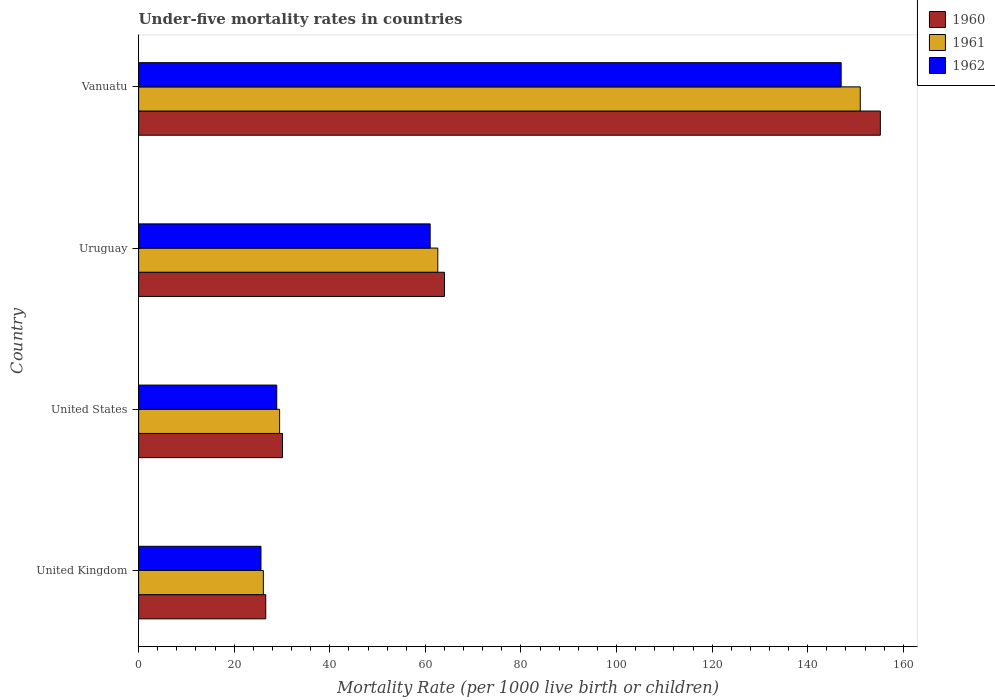How many different coloured bars are there?
Your response must be concise. 3. How many groups of bars are there?
Make the answer very short. 4. Are the number of bars per tick equal to the number of legend labels?
Your response must be concise. Yes. What is the label of the 4th group of bars from the top?
Offer a very short reply. United Kingdom. What is the under-five mortality rate in 1962 in United Kingdom?
Your answer should be very brief. 25.6. Across all countries, what is the maximum under-five mortality rate in 1960?
Offer a terse response. 155.2. Across all countries, what is the minimum under-five mortality rate in 1960?
Your response must be concise. 26.6. In which country was the under-five mortality rate in 1961 maximum?
Keep it short and to the point. Vanuatu. What is the total under-five mortality rate in 1962 in the graph?
Your answer should be very brief. 262.5. What is the difference between the under-five mortality rate in 1962 in United States and that in Vanuatu?
Give a very brief answer. -118.1. What is the difference between the under-five mortality rate in 1962 in United Kingdom and the under-five mortality rate in 1960 in United States?
Make the answer very short. -4.5. What is the average under-five mortality rate in 1960 per country?
Offer a very short reply. 68.97. What is the difference between the under-five mortality rate in 1962 and under-five mortality rate in 1961 in Uruguay?
Provide a succinct answer. -1.6. In how many countries, is the under-five mortality rate in 1961 greater than 76 ?
Keep it short and to the point. 1. What is the ratio of the under-five mortality rate in 1960 in United States to that in Uruguay?
Make the answer very short. 0.47. What is the difference between the highest and the lowest under-five mortality rate in 1962?
Offer a terse response. 121.4. In how many countries, is the under-five mortality rate in 1960 greater than the average under-five mortality rate in 1960 taken over all countries?
Ensure brevity in your answer.  1. What does the 2nd bar from the bottom in Vanuatu represents?
Provide a short and direct response. 1961. Is it the case that in every country, the sum of the under-five mortality rate in 1962 and under-five mortality rate in 1960 is greater than the under-five mortality rate in 1961?
Your answer should be very brief. Yes. How many bars are there?
Your response must be concise. 12. Are all the bars in the graph horizontal?
Ensure brevity in your answer.  Yes. What is the difference between two consecutive major ticks on the X-axis?
Provide a short and direct response. 20. Are the values on the major ticks of X-axis written in scientific E-notation?
Provide a short and direct response. No. Does the graph contain grids?
Ensure brevity in your answer.  No. Where does the legend appear in the graph?
Keep it short and to the point. Top right. How many legend labels are there?
Give a very brief answer. 3. What is the title of the graph?
Ensure brevity in your answer.  Under-five mortality rates in countries. What is the label or title of the X-axis?
Your answer should be very brief. Mortality Rate (per 1000 live birth or children). What is the label or title of the Y-axis?
Offer a very short reply. Country. What is the Mortality Rate (per 1000 live birth or children) in 1960 in United Kingdom?
Provide a succinct answer. 26.6. What is the Mortality Rate (per 1000 live birth or children) in 1961 in United Kingdom?
Your answer should be very brief. 26.1. What is the Mortality Rate (per 1000 live birth or children) in 1962 in United Kingdom?
Offer a terse response. 25.6. What is the Mortality Rate (per 1000 live birth or children) in 1960 in United States?
Make the answer very short. 30.1. What is the Mortality Rate (per 1000 live birth or children) in 1961 in United States?
Keep it short and to the point. 29.5. What is the Mortality Rate (per 1000 live birth or children) in 1962 in United States?
Offer a terse response. 28.9. What is the Mortality Rate (per 1000 live birth or children) in 1961 in Uruguay?
Provide a short and direct response. 62.6. What is the Mortality Rate (per 1000 live birth or children) in 1960 in Vanuatu?
Offer a very short reply. 155.2. What is the Mortality Rate (per 1000 live birth or children) of 1961 in Vanuatu?
Provide a succinct answer. 151. What is the Mortality Rate (per 1000 live birth or children) in 1962 in Vanuatu?
Make the answer very short. 147. Across all countries, what is the maximum Mortality Rate (per 1000 live birth or children) of 1960?
Give a very brief answer. 155.2. Across all countries, what is the maximum Mortality Rate (per 1000 live birth or children) of 1961?
Your response must be concise. 151. Across all countries, what is the maximum Mortality Rate (per 1000 live birth or children) in 1962?
Provide a succinct answer. 147. Across all countries, what is the minimum Mortality Rate (per 1000 live birth or children) in 1960?
Offer a very short reply. 26.6. Across all countries, what is the minimum Mortality Rate (per 1000 live birth or children) in 1961?
Offer a very short reply. 26.1. Across all countries, what is the minimum Mortality Rate (per 1000 live birth or children) of 1962?
Offer a terse response. 25.6. What is the total Mortality Rate (per 1000 live birth or children) of 1960 in the graph?
Provide a short and direct response. 275.9. What is the total Mortality Rate (per 1000 live birth or children) in 1961 in the graph?
Offer a terse response. 269.2. What is the total Mortality Rate (per 1000 live birth or children) of 1962 in the graph?
Give a very brief answer. 262.5. What is the difference between the Mortality Rate (per 1000 live birth or children) of 1960 in United Kingdom and that in Uruguay?
Provide a succinct answer. -37.4. What is the difference between the Mortality Rate (per 1000 live birth or children) in 1961 in United Kingdom and that in Uruguay?
Offer a terse response. -36.5. What is the difference between the Mortality Rate (per 1000 live birth or children) in 1962 in United Kingdom and that in Uruguay?
Offer a terse response. -35.4. What is the difference between the Mortality Rate (per 1000 live birth or children) in 1960 in United Kingdom and that in Vanuatu?
Keep it short and to the point. -128.6. What is the difference between the Mortality Rate (per 1000 live birth or children) of 1961 in United Kingdom and that in Vanuatu?
Provide a succinct answer. -124.9. What is the difference between the Mortality Rate (per 1000 live birth or children) of 1962 in United Kingdom and that in Vanuatu?
Your answer should be compact. -121.4. What is the difference between the Mortality Rate (per 1000 live birth or children) of 1960 in United States and that in Uruguay?
Make the answer very short. -33.9. What is the difference between the Mortality Rate (per 1000 live birth or children) in 1961 in United States and that in Uruguay?
Provide a short and direct response. -33.1. What is the difference between the Mortality Rate (per 1000 live birth or children) in 1962 in United States and that in Uruguay?
Give a very brief answer. -32.1. What is the difference between the Mortality Rate (per 1000 live birth or children) of 1960 in United States and that in Vanuatu?
Keep it short and to the point. -125.1. What is the difference between the Mortality Rate (per 1000 live birth or children) in 1961 in United States and that in Vanuatu?
Make the answer very short. -121.5. What is the difference between the Mortality Rate (per 1000 live birth or children) in 1962 in United States and that in Vanuatu?
Your answer should be compact. -118.1. What is the difference between the Mortality Rate (per 1000 live birth or children) in 1960 in Uruguay and that in Vanuatu?
Your response must be concise. -91.2. What is the difference between the Mortality Rate (per 1000 live birth or children) of 1961 in Uruguay and that in Vanuatu?
Make the answer very short. -88.4. What is the difference between the Mortality Rate (per 1000 live birth or children) of 1962 in Uruguay and that in Vanuatu?
Your response must be concise. -86. What is the difference between the Mortality Rate (per 1000 live birth or children) in 1960 in United Kingdom and the Mortality Rate (per 1000 live birth or children) in 1962 in United States?
Keep it short and to the point. -2.3. What is the difference between the Mortality Rate (per 1000 live birth or children) in 1961 in United Kingdom and the Mortality Rate (per 1000 live birth or children) in 1962 in United States?
Provide a succinct answer. -2.8. What is the difference between the Mortality Rate (per 1000 live birth or children) of 1960 in United Kingdom and the Mortality Rate (per 1000 live birth or children) of 1961 in Uruguay?
Offer a very short reply. -36. What is the difference between the Mortality Rate (per 1000 live birth or children) in 1960 in United Kingdom and the Mortality Rate (per 1000 live birth or children) in 1962 in Uruguay?
Your answer should be compact. -34.4. What is the difference between the Mortality Rate (per 1000 live birth or children) in 1961 in United Kingdom and the Mortality Rate (per 1000 live birth or children) in 1962 in Uruguay?
Offer a terse response. -34.9. What is the difference between the Mortality Rate (per 1000 live birth or children) of 1960 in United Kingdom and the Mortality Rate (per 1000 live birth or children) of 1961 in Vanuatu?
Keep it short and to the point. -124.4. What is the difference between the Mortality Rate (per 1000 live birth or children) of 1960 in United Kingdom and the Mortality Rate (per 1000 live birth or children) of 1962 in Vanuatu?
Offer a terse response. -120.4. What is the difference between the Mortality Rate (per 1000 live birth or children) of 1961 in United Kingdom and the Mortality Rate (per 1000 live birth or children) of 1962 in Vanuatu?
Offer a very short reply. -120.9. What is the difference between the Mortality Rate (per 1000 live birth or children) in 1960 in United States and the Mortality Rate (per 1000 live birth or children) in 1961 in Uruguay?
Ensure brevity in your answer.  -32.5. What is the difference between the Mortality Rate (per 1000 live birth or children) of 1960 in United States and the Mortality Rate (per 1000 live birth or children) of 1962 in Uruguay?
Ensure brevity in your answer.  -30.9. What is the difference between the Mortality Rate (per 1000 live birth or children) of 1961 in United States and the Mortality Rate (per 1000 live birth or children) of 1962 in Uruguay?
Your answer should be very brief. -31.5. What is the difference between the Mortality Rate (per 1000 live birth or children) in 1960 in United States and the Mortality Rate (per 1000 live birth or children) in 1961 in Vanuatu?
Offer a very short reply. -120.9. What is the difference between the Mortality Rate (per 1000 live birth or children) in 1960 in United States and the Mortality Rate (per 1000 live birth or children) in 1962 in Vanuatu?
Keep it short and to the point. -116.9. What is the difference between the Mortality Rate (per 1000 live birth or children) in 1961 in United States and the Mortality Rate (per 1000 live birth or children) in 1962 in Vanuatu?
Offer a terse response. -117.5. What is the difference between the Mortality Rate (per 1000 live birth or children) in 1960 in Uruguay and the Mortality Rate (per 1000 live birth or children) in 1961 in Vanuatu?
Your answer should be compact. -87. What is the difference between the Mortality Rate (per 1000 live birth or children) of 1960 in Uruguay and the Mortality Rate (per 1000 live birth or children) of 1962 in Vanuatu?
Your answer should be compact. -83. What is the difference between the Mortality Rate (per 1000 live birth or children) in 1961 in Uruguay and the Mortality Rate (per 1000 live birth or children) in 1962 in Vanuatu?
Ensure brevity in your answer.  -84.4. What is the average Mortality Rate (per 1000 live birth or children) in 1960 per country?
Keep it short and to the point. 68.97. What is the average Mortality Rate (per 1000 live birth or children) in 1961 per country?
Give a very brief answer. 67.3. What is the average Mortality Rate (per 1000 live birth or children) of 1962 per country?
Keep it short and to the point. 65.62. What is the difference between the Mortality Rate (per 1000 live birth or children) of 1960 and Mortality Rate (per 1000 live birth or children) of 1961 in United Kingdom?
Keep it short and to the point. 0.5. What is the difference between the Mortality Rate (per 1000 live birth or children) of 1960 and Mortality Rate (per 1000 live birth or children) of 1962 in United Kingdom?
Your answer should be very brief. 1. What is the difference between the Mortality Rate (per 1000 live birth or children) in 1960 and Mortality Rate (per 1000 live birth or children) in 1962 in United States?
Your answer should be very brief. 1.2. What is the difference between the Mortality Rate (per 1000 live birth or children) in 1960 and Mortality Rate (per 1000 live birth or children) in 1962 in Uruguay?
Provide a short and direct response. 3. What is the difference between the Mortality Rate (per 1000 live birth or children) in 1960 and Mortality Rate (per 1000 live birth or children) in 1961 in Vanuatu?
Keep it short and to the point. 4.2. What is the difference between the Mortality Rate (per 1000 live birth or children) in 1961 and Mortality Rate (per 1000 live birth or children) in 1962 in Vanuatu?
Your answer should be compact. 4. What is the ratio of the Mortality Rate (per 1000 live birth or children) of 1960 in United Kingdom to that in United States?
Your response must be concise. 0.88. What is the ratio of the Mortality Rate (per 1000 live birth or children) in 1961 in United Kingdom to that in United States?
Provide a succinct answer. 0.88. What is the ratio of the Mortality Rate (per 1000 live birth or children) of 1962 in United Kingdom to that in United States?
Make the answer very short. 0.89. What is the ratio of the Mortality Rate (per 1000 live birth or children) in 1960 in United Kingdom to that in Uruguay?
Your answer should be compact. 0.42. What is the ratio of the Mortality Rate (per 1000 live birth or children) in 1961 in United Kingdom to that in Uruguay?
Your answer should be compact. 0.42. What is the ratio of the Mortality Rate (per 1000 live birth or children) in 1962 in United Kingdom to that in Uruguay?
Make the answer very short. 0.42. What is the ratio of the Mortality Rate (per 1000 live birth or children) of 1960 in United Kingdom to that in Vanuatu?
Offer a terse response. 0.17. What is the ratio of the Mortality Rate (per 1000 live birth or children) in 1961 in United Kingdom to that in Vanuatu?
Your answer should be very brief. 0.17. What is the ratio of the Mortality Rate (per 1000 live birth or children) of 1962 in United Kingdom to that in Vanuatu?
Ensure brevity in your answer.  0.17. What is the ratio of the Mortality Rate (per 1000 live birth or children) of 1960 in United States to that in Uruguay?
Give a very brief answer. 0.47. What is the ratio of the Mortality Rate (per 1000 live birth or children) of 1961 in United States to that in Uruguay?
Provide a short and direct response. 0.47. What is the ratio of the Mortality Rate (per 1000 live birth or children) in 1962 in United States to that in Uruguay?
Your answer should be compact. 0.47. What is the ratio of the Mortality Rate (per 1000 live birth or children) of 1960 in United States to that in Vanuatu?
Offer a terse response. 0.19. What is the ratio of the Mortality Rate (per 1000 live birth or children) of 1961 in United States to that in Vanuatu?
Your answer should be compact. 0.2. What is the ratio of the Mortality Rate (per 1000 live birth or children) in 1962 in United States to that in Vanuatu?
Your response must be concise. 0.2. What is the ratio of the Mortality Rate (per 1000 live birth or children) of 1960 in Uruguay to that in Vanuatu?
Give a very brief answer. 0.41. What is the ratio of the Mortality Rate (per 1000 live birth or children) in 1961 in Uruguay to that in Vanuatu?
Ensure brevity in your answer.  0.41. What is the ratio of the Mortality Rate (per 1000 live birth or children) in 1962 in Uruguay to that in Vanuatu?
Your answer should be compact. 0.41. What is the difference between the highest and the second highest Mortality Rate (per 1000 live birth or children) of 1960?
Offer a terse response. 91.2. What is the difference between the highest and the second highest Mortality Rate (per 1000 live birth or children) of 1961?
Your answer should be compact. 88.4. What is the difference between the highest and the lowest Mortality Rate (per 1000 live birth or children) in 1960?
Your response must be concise. 128.6. What is the difference between the highest and the lowest Mortality Rate (per 1000 live birth or children) of 1961?
Ensure brevity in your answer.  124.9. What is the difference between the highest and the lowest Mortality Rate (per 1000 live birth or children) of 1962?
Provide a succinct answer. 121.4. 